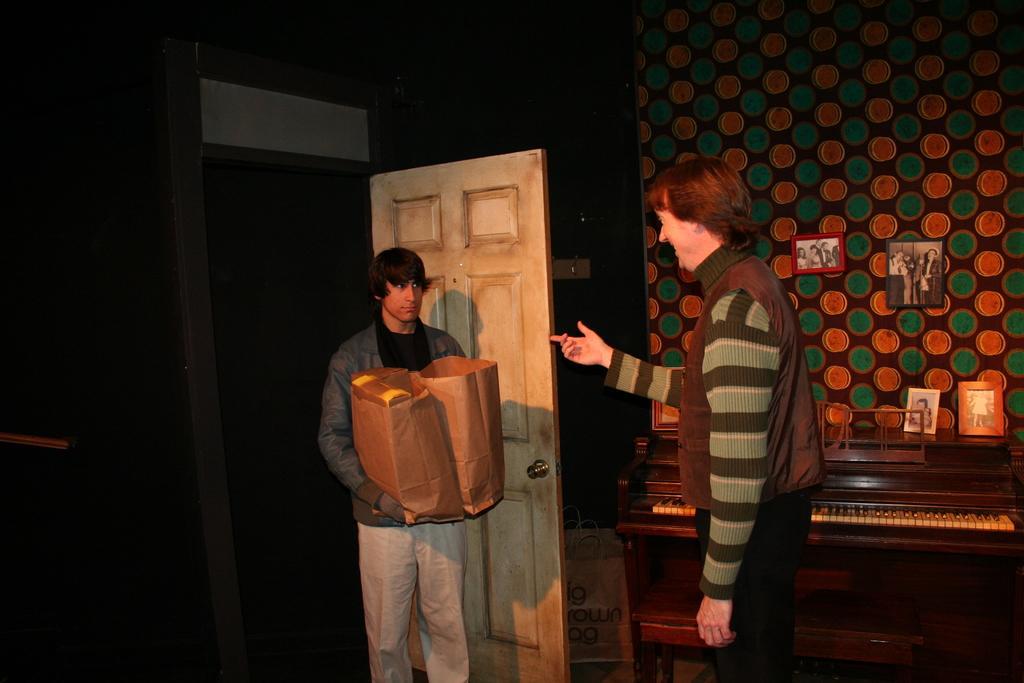Please provide a concise description of this image. In the center of the image there is a person standing with bags at the door. On the right side of the image there is a person standing on the floor. On the right side we can see piano, photo frames and wall. In the background there is a wall and door. 